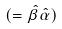Convert formula to latex. <formula><loc_0><loc_0><loc_500><loc_500>( = \hat { \beta } \hat { \alpha } )</formula> 